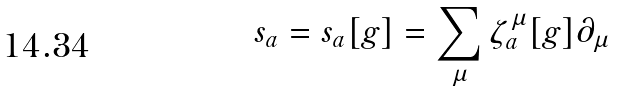Convert formula to latex. <formula><loc_0><loc_0><loc_500><loc_500>s _ { a } = s _ { a } [ g ] = \sum _ { \mu } \zeta ^ { \mu } _ { a } [ g ] \partial _ { \mu }</formula> 